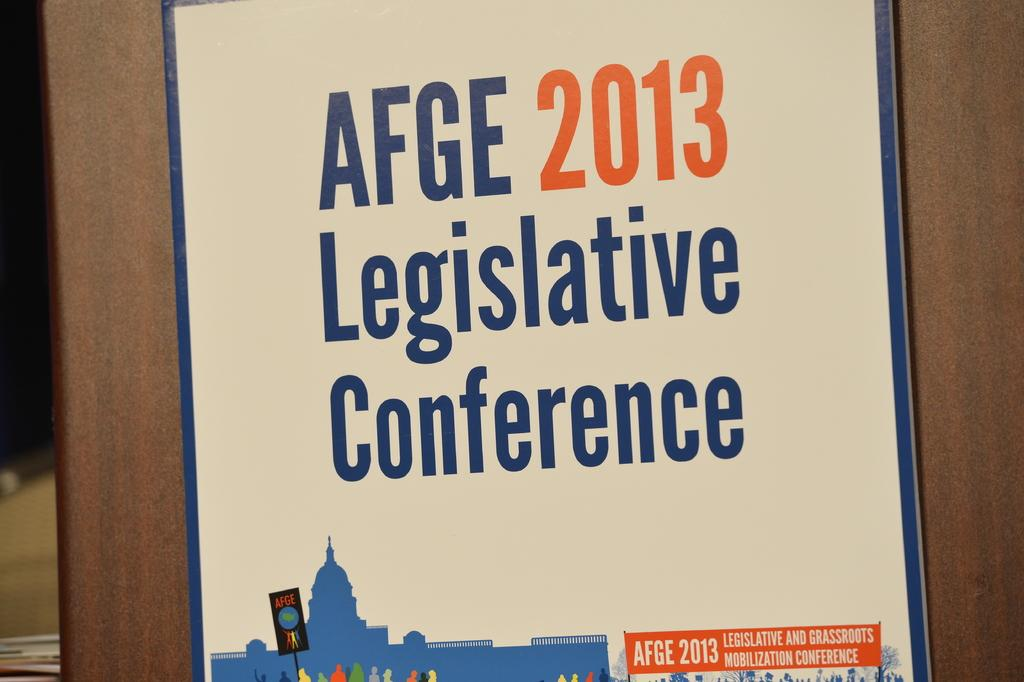<image>
Share a concise interpretation of the image provided. A poster hangs on a wall which says it is 2013 and you are at the AFGE Legislative Conference 